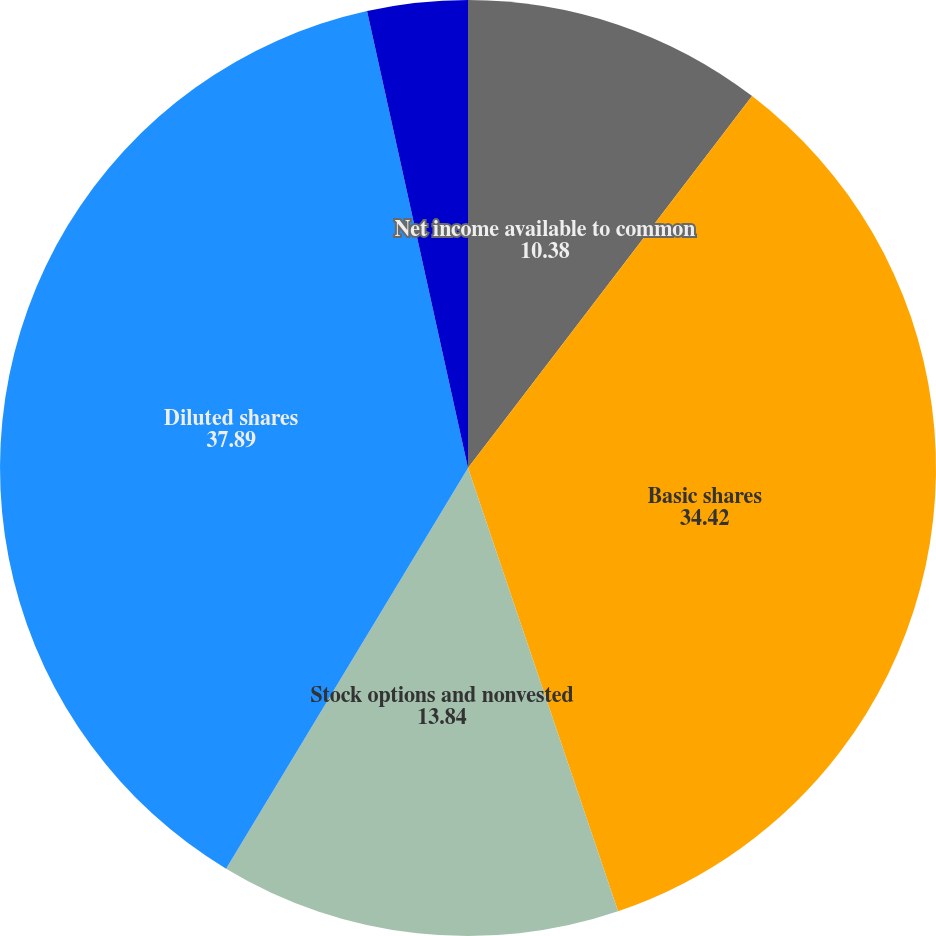Convert chart to OTSL. <chart><loc_0><loc_0><loc_500><loc_500><pie_chart><fcel>Net income available to common<fcel>Basic shares<fcel>Stock options and nonvested<fcel>Diluted shares<fcel>Basic earnings per share<fcel>Diluted earnings per share<nl><fcel>10.38%<fcel>34.42%<fcel>13.84%<fcel>37.89%<fcel>0.0%<fcel>3.46%<nl></chart> 